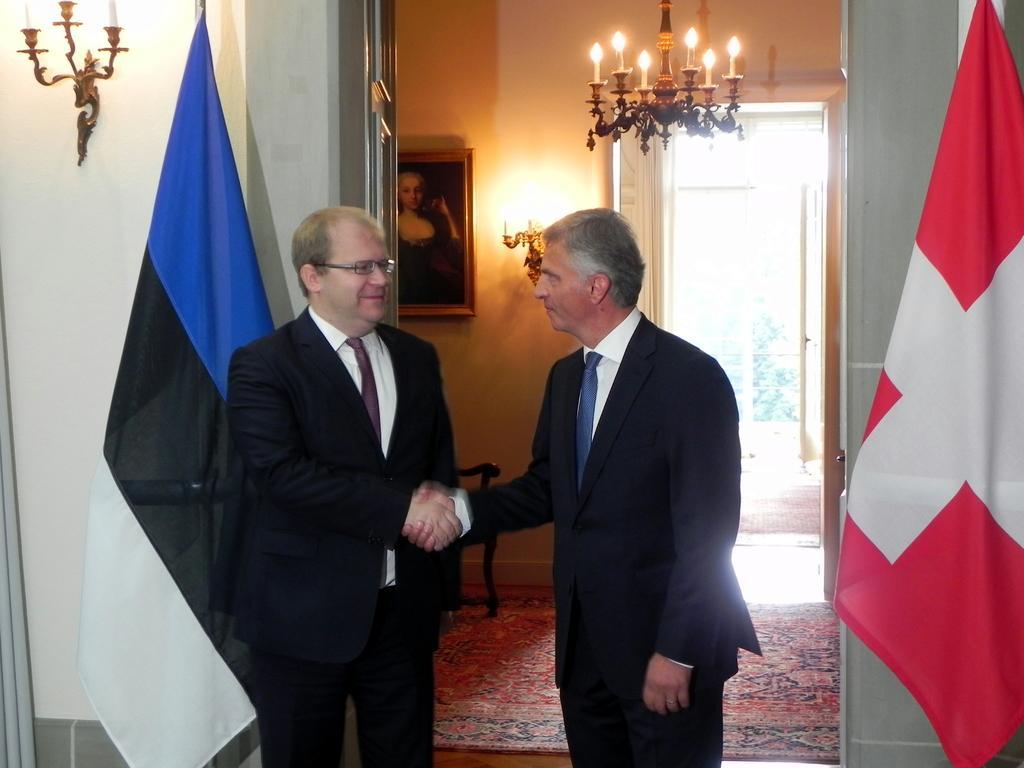Please provide a concise description of this image. In this image there are two men shaking their hands, on either side of them there are flags, walls,in the background there is a wall for that wall there is a photo frame, light at the top there is a chandelier. 